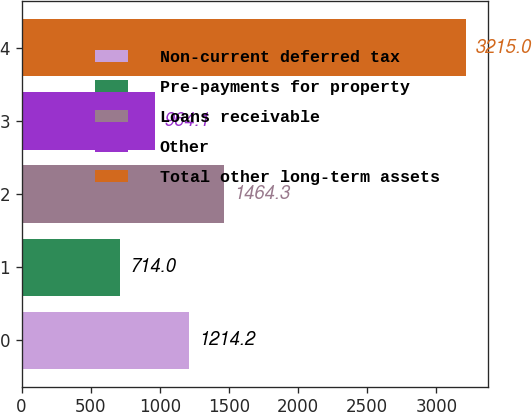Convert chart to OTSL. <chart><loc_0><loc_0><loc_500><loc_500><bar_chart><fcel>Non-current deferred tax<fcel>Pre-payments for property<fcel>Loans receivable<fcel>Other<fcel>Total other long-term assets<nl><fcel>1214.2<fcel>714<fcel>1464.3<fcel>964.1<fcel>3215<nl></chart> 